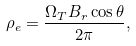Convert formula to latex. <formula><loc_0><loc_0><loc_500><loc_500>\rho _ { e } = \frac { \Omega _ { T } B _ { r } \cos \theta } { 2 \pi } ,</formula> 